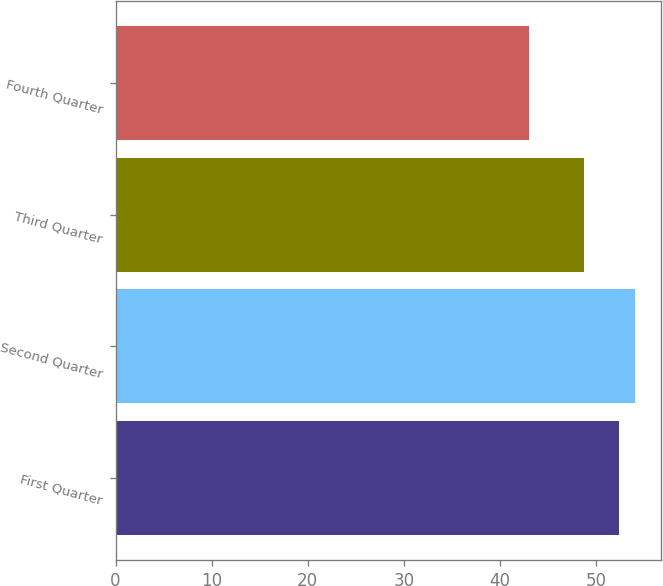Convert chart to OTSL. <chart><loc_0><loc_0><loc_500><loc_500><bar_chart><fcel>First Quarter<fcel>Second Quarter<fcel>Third Quarter<fcel>Fourth Quarter<nl><fcel>52.41<fcel>54.12<fcel>48.78<fcel>43.06<nl></chart> 